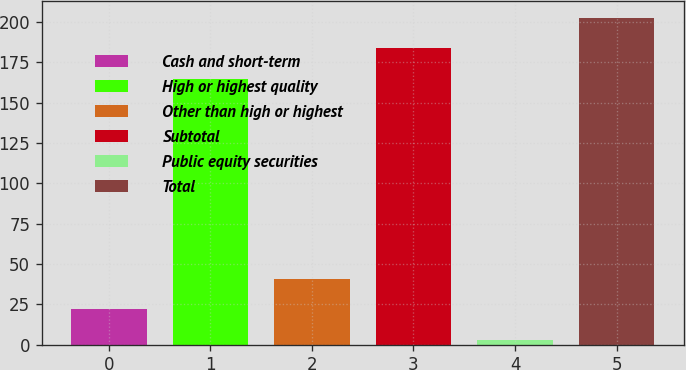Convert chart to OTSL. <chart><loc_0><loc_0><loc_500><loc_500><bar_chart><fcel>Cash and short-term<fcel>High or highest quality<fcel>Other than high or highest<fcel>Subtotal<fcel>Public equity securities<fcel>Total<nl><fcel>22.03<fcel>164.7<fcel>41.06<fcel>183.73<fcel>3<fcel>202.76<nl></chart> 